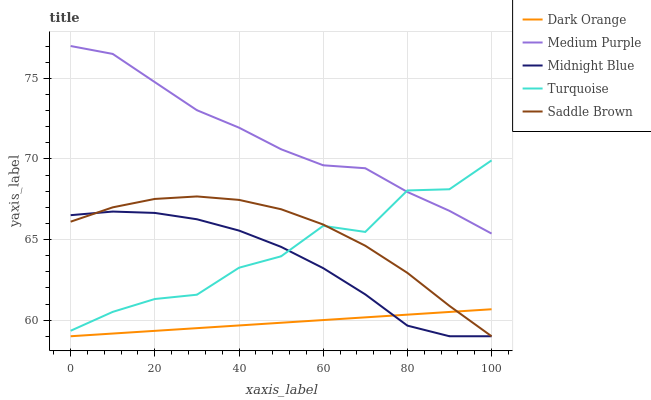Does Dark Orange have the minimum area under the curve?
Answer yes or no. Yes. Does Medium Purple have the maximum area under the curve?
Answer yes or no. Yes. Does Turquoise have the minimum area under the curve?
Answer yes or no. No. Does Turquoise have the maximum area under the curve?
Answer yes or no. No. Is Dark Orange the smoothest?
Answer yes or no. Yes. Is Turquoise the roughest?
Answer yes or no. Yes. Is Turquoise the smoothest?
Answer yes or no. No. Is Dark Orange the roughest?
Answer yes or no. No. Does Dark Orange have the lowest value?
Answer yes or no. Yes. Does Turquoise have the lowest value?
Answer yes or no. No. Does Medium Purple have the highest value?
Answer yes or no. Yes. Does Turquoise have the highest value?
Answer yes or no. No. Is Dark Orange less than Turquoise?
Answer yes or no. Yes. Is Medium Purple greater than Midnight Blue?
Answer yes or no. Yes. Does Saddle Brown intersect Dark Orange?
Answer yes or no. Yes. Is Saddle Brown less than Dark Orange?
Answer yes or no. No. Is Saddle Brown greater than Dark Orange?
Answer yes or no. No. Does Dark Orange intersect Turquoise?
Answer yes or no. No. 